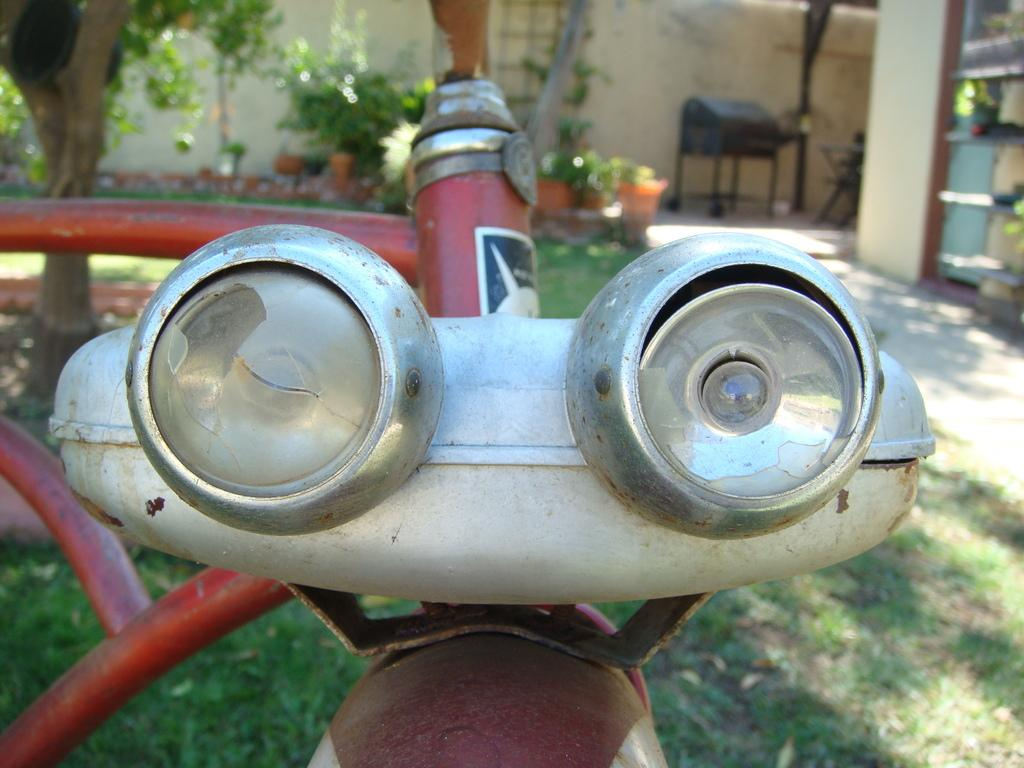What is the main subject in the center of the image? There are lights of a bicycle in the center of the image. What can be seen in the background of the image? There are trees, grass, a building, pots, and a wall in the background of the image. How many knots are tied on the coat in the image? There is no coat present in the image, and therefore no knots can be observed. 